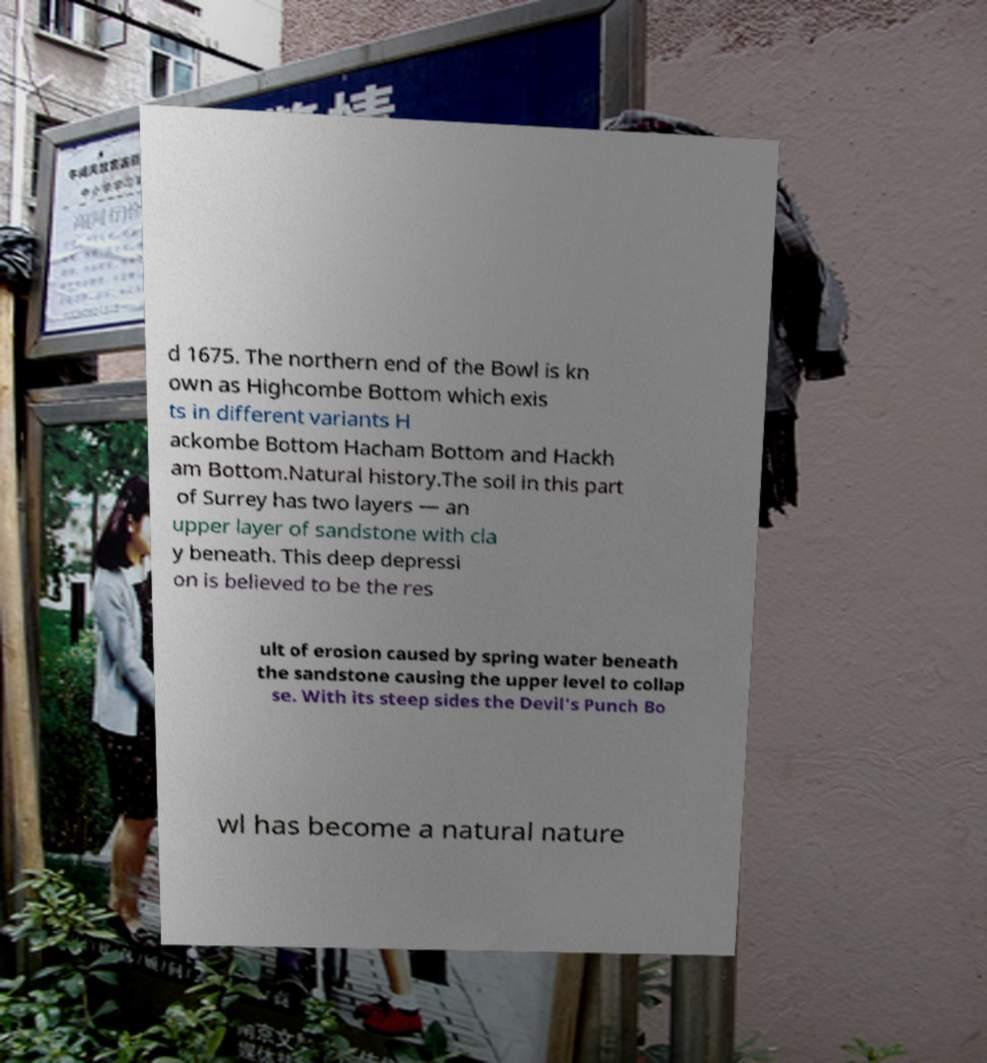What messages or text are displayed in this image? I need them in a readable, typed format. d 1675. The northern end of the Bowl is kn own as Highcombe Bottom which exis ts in different variants H ackombe Bottom Hacham Bottom and Hackh am Bottom.Natural history.The soil in this part of Surrey has two layers — an upper layer of sandstone with cla y beneath. This deep depressi on is believed to be the res ult of erosion caused by spring water beneath the sandstone causing the upper level to collap se. With its steep sides the Devil's Punch Bo wl has become a natural nature 